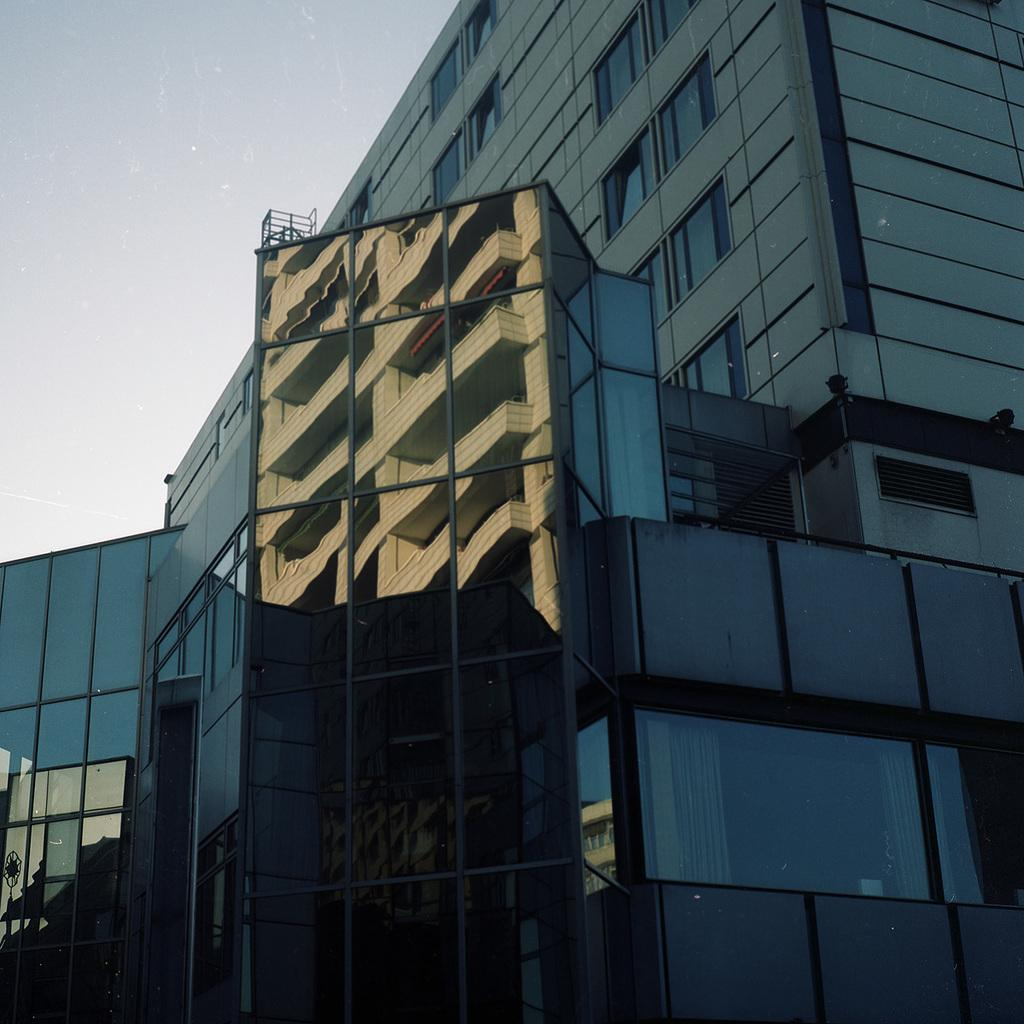What type of structure is present in the image? There is a building in the image. What can be seen in the background of the image? The sky is visible in the background of the image. What type of cheese is being served at the event in the image? There is no event or cheese present in the image; it only features a building and the sky. 